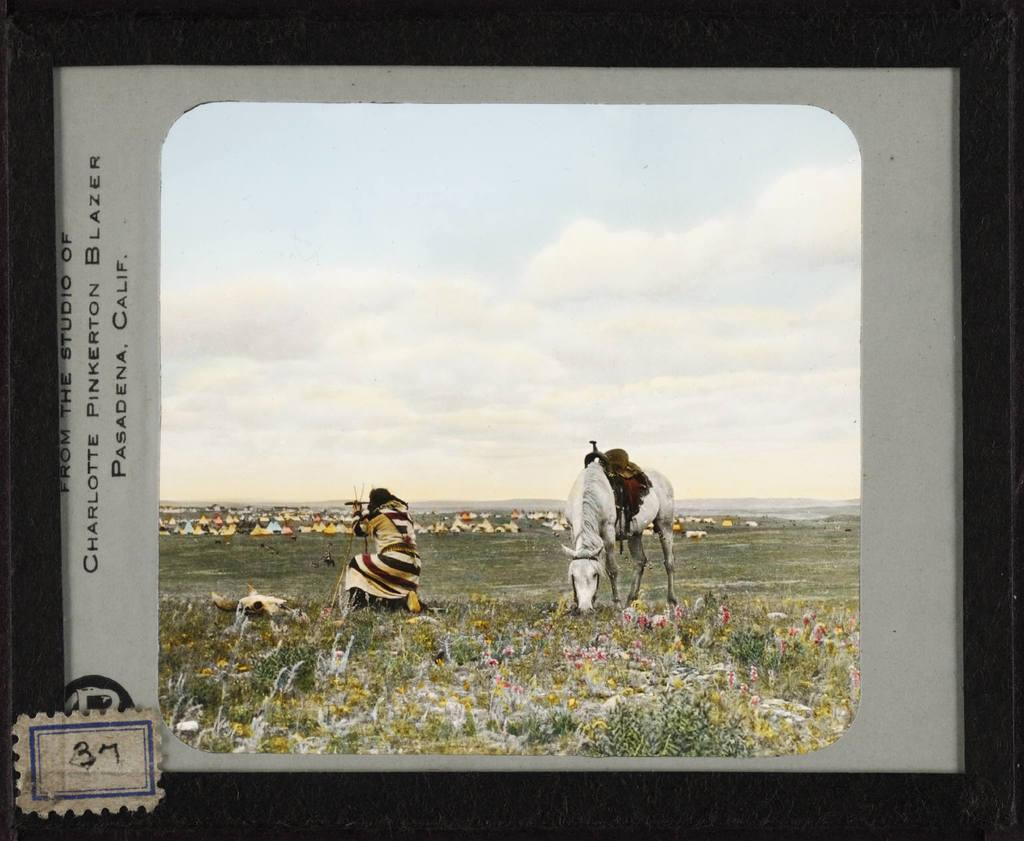<image>
Render a clear and concise summary of the photo. a photograph of a horse in pasadena claifornia 